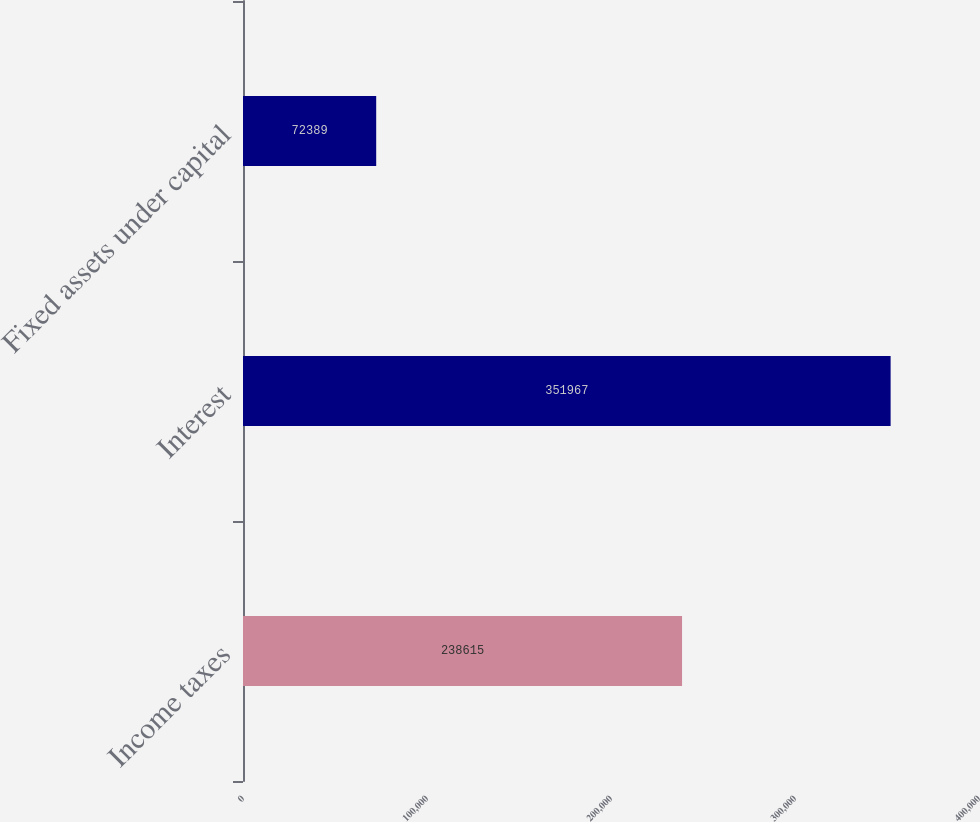<chart> <loc_0><loc_0><loc_500><loc_500><bar_chart><fcel>Income taxes<fcel>Interest<fcel>Fixed assets under capital<nl><fcel>238615<fcel>351967<fcel>72389<nl></chart> 